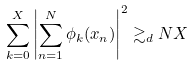Convert formula to latex. <formula><loc_0><loc_0><loc_500><loc_500>\sum _ { k = 0 } ^ { X } { \left | \sum _ { n = 1 } ^ { N } { \phi _ { k } ( x _ { n } ) } \right | ^ { 2 } } \gtrsim _ { d } N X</formula> 